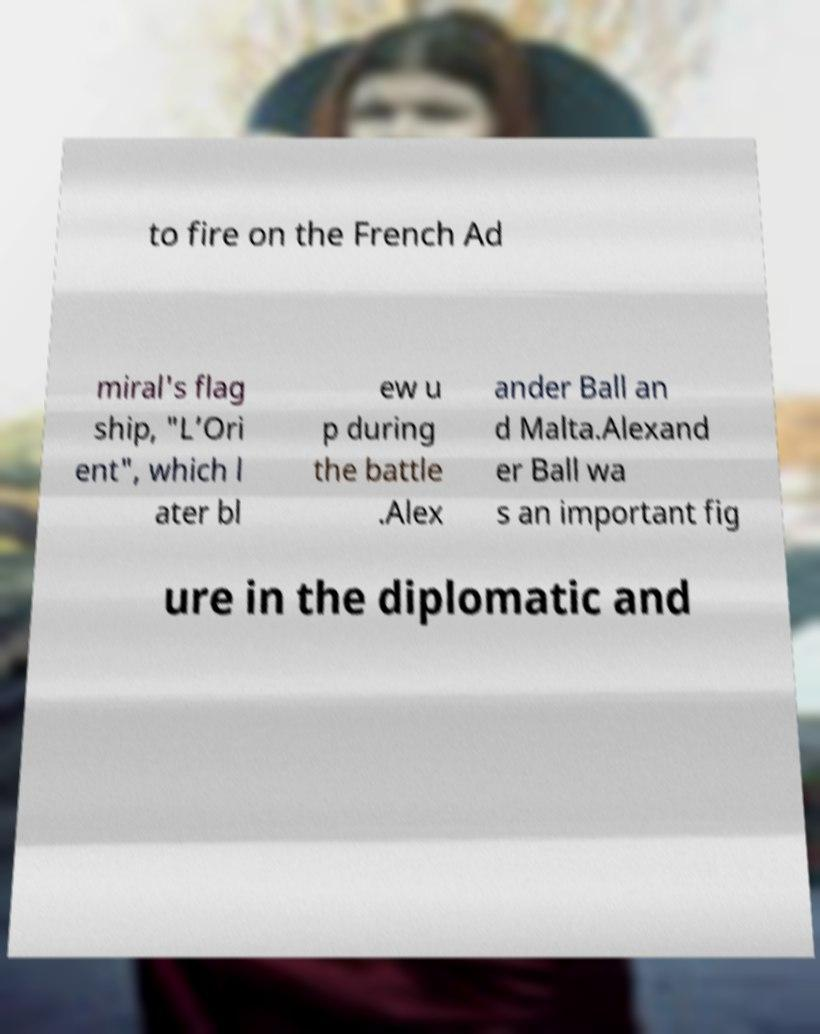Could you assist in decoding the text presented in this image and type it out clearly? to fire on the French Ad miral's flag ship, "L’Ori ent", which l ater bl ew u p during the battle .Alex ander Ball an d Malta.Alexand er Ball wa s an important fig ure in the diplomatic and 